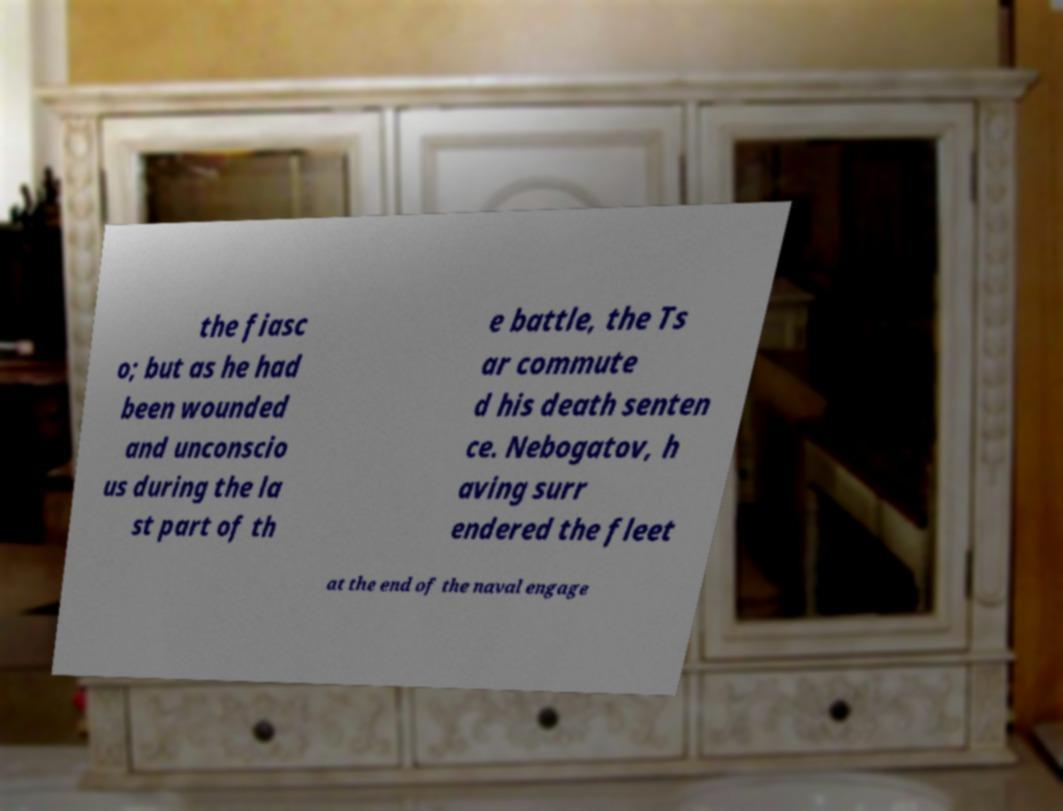Please identify and transcribe the text found in this image. the fiasc o; but as he had been wounded and unconscio us during the la st part of th e battle, the Ts ar commute d his death senten ce. Nebogatov, h aving surr endered the fleet at the end of the naval engage 